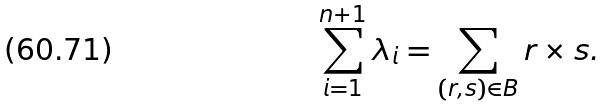<formula> <loc_0><loc_0><loc_500><loc_500>\sum _ { i = 1 } ^ { n + 1 } \lambda _ { i } = \sum _ { ( r , s ) \in B } r \times s .</formula> 